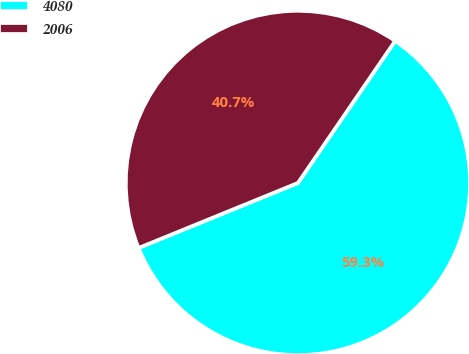Convert chart. <chart><loc_0><loc_0><loc_500><loc_500><pie_chart><fcel>4080<fcel>2006<nl><fcel>59.28%<fcel>40.72%<nl></chart> 